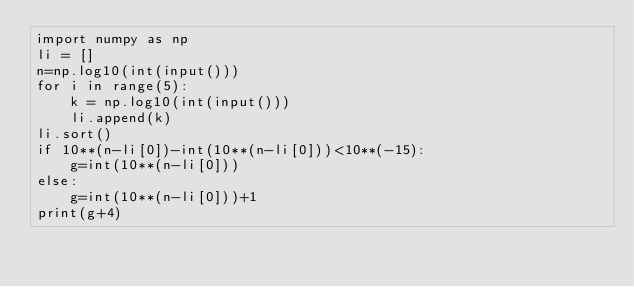Convert code to text. <code><loc_0><loc_0><loc_500><loc_500><_Python_>import numpy as np
li = []
n=np.log10(int(input()))
for i in range(5):
    k = np.log10(int(input()))
    li.append(k)
li.sort()
if 10**(n-li[0])-int(10**(n-li[0]))<10**(-15):
    g=int(10**(n-li[0]))
else:
    g=int(10**(n-li[0]))+1
print(g+4)   </code> 